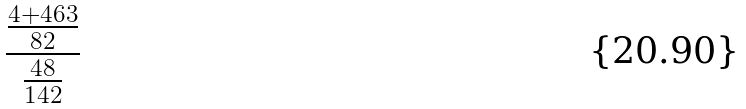<formula> <loc_0><loc_0><loc_500><loc_500>\frac { \frac { 4 + 4 6 3 } { 8 2 } } { \frac { 4 8 } { 1 4 2 } }</formula> 